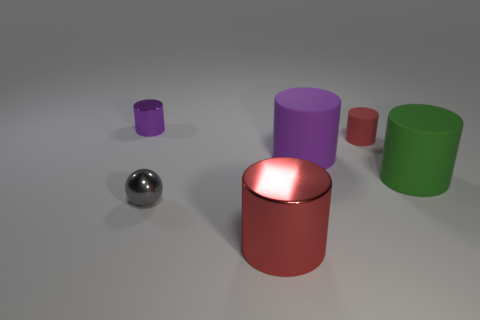There is a matte object that is the same color as the big shiny cylinder; what size is it?
Your answer should be very brief. Small. There is a tiny metal thing behind the big green object; what color is it?
Keep it short and to the point. Purple. There is a small thing on the left side of the small shiny ball; is it the same color as the small sphere?
Keep it short and to the point. No. The green rubber object that is the same shape as the purple metal thing is what size?
Your answer should be very brief. Large. Is there any other thing that is the same size as the green rubber cylinder?
Offer a very short reply. Yes. What material is the large object in front of the big rubber thing in front of the purple cylinder on the right side of the small purple shiny thing?
Your response must be concise. Metal. Is the number of small gray balls on the right side of the big purple cylinder greater than the number of big matte objects that are on the left side of the small purple metallic thing?
Your answer should be compact. No. Do the gray metal ball and the red matte object have the same size?
Offer a very short reply. Yes. There is a small rubber thing that is the same shape as the red metal thing; what color is it?
Your answer should be compact. Red. How many other large metallic objects are the same color as the large shiny object?
Ensure brevity in your answer.  0. 